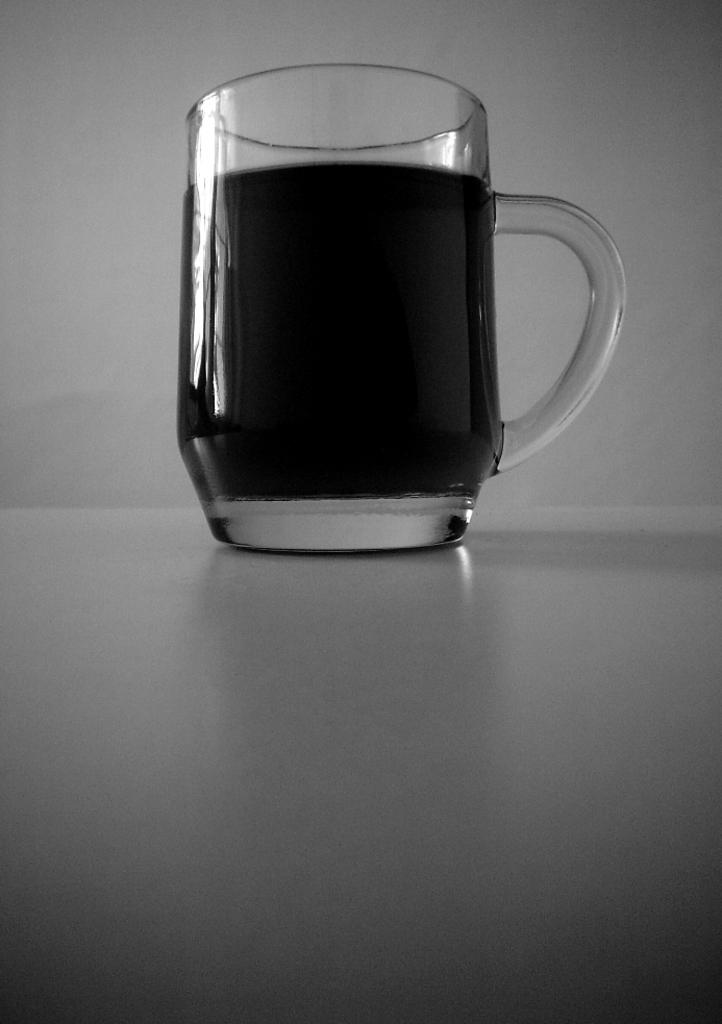What is in the glass that is visible in the image? There is a drink in the glass in the image. Where is the glass located in the image? The glass is on the floor in the image. What is visible behind the glass in the image? There is a wall visible behind the glass in the image. How many wrens can be seen perched on the glass in the image? There are no wrens present in the image. What type of brake system is visible on the wall behind the glass in the image? There is no brake system visible in the image. 